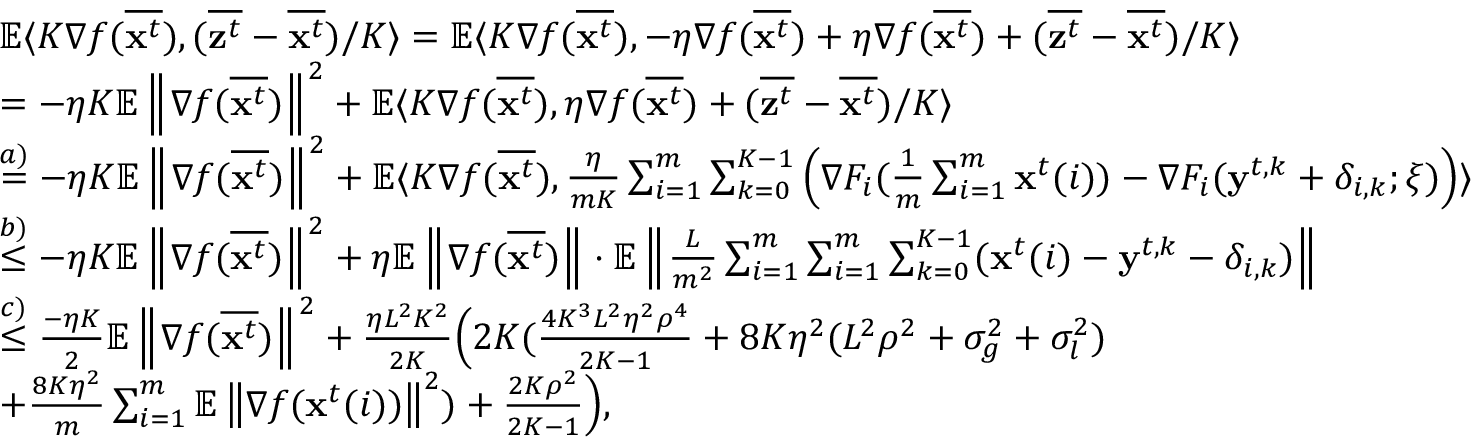<formula> <loc_0><loc_0><loc_500><loc_500>\begin{array} { r l } & { \mathbb { E } \langle K \nabla f ( \overline { { x ^ { t } } } ) , ( \overline { { z ^ { t } } } - \overline { { x ^ { t } } } ) / K \rangle = \mathbb { E } \langle K \nabla f ( \overline { { { x } ^ { t } } } ) , - \eta \nabla f ( \overline { { { x } ^ { t } } } ) + \eta \nabla f ( \overline { { { x } ^ { t } } } ) + ( \overline { { { z } ^ { t } } } - \overline { { { x } ^ { t } } } ) / K \rangle } \\ & { = - \eta K \mathbb { E } \left \| \nabla f ( \overline { { x ^ { t } } } ) \right \| ^ { 2 } + \mathbb { E } \langle K \nabla f ( \overline { { { x } ^ { t } } } ) , \eta \nabla f ( \overline { { { x } ^ { t } } } ) + ( \overline { { { z } ^ { t } } } - \overline { { { x } ^ { t } } } ) / K \rangle } \\ & { \overset { a ) } { = } - \eta K \mathbb { E } \left \| \nabla f ( \overline { { x ^ { t } } } ) \right \| ^ { 2 } + \mathbb { E } \langle K \nabla f ( \overline { { x ^ { t } } } ) , \frac { \eta } { m K } \sum _ { i = 1 } ^ { m } \sum _ { k = 0 } ^ { K - 1 } \left ( \nabla F _ { i } ( \frac { 1 } { m } \sum _ { i = 1 } ^ { m } x ^ { t } ( i ) ) - \nabla F _ { i } ( y ^ { t , k } + \delta _ { i , k } ; \xi ) \right ) \rangle } \\ & { \overset { b ) } { \leq } - \eta K \mathbb { E } \left \| \nabla f ( \overline { { x ^ { t } } } ) \right \| ^ { 2 } + \eta \mathbb { E } \left \| \nabla f ( \overline { { x ^ { t } } } ) \right \| \cdot \mathbb { E } \left \| \frac { L } { m ^ { 2 } } \sum _ { i = 1 } ^ { m } \sum _ { i = 1 } ^ { m } \sum _ { k = 0 } ^ { K - 1 } ( x ^ { t } ( i ) - y ^ { t , k } - \delta _ { i , k } ) \right \| } \\ & { \overset { c ) } { \leq } \frac { - \eta K } { 2 } \mathbb { E } \left \| \nabla f ( \overline { { x ^ { t } } } ) \right \| ^ { 2 } + \frac { \eta L ^ { 2 } K ^ { 2 } } { 2 K } \left ( 2 K ( \frac { 4 K ^ { 3 } L ^ { 2 } \eta ^ { 2 } \rho ^ { 4 } } { 2 K - 1 } + 8 K \eta ^ { 2 } ( L ^ { 2 } \rho ^ { 2 } + \sigma _ { g } ^ { 2 } + \sigma _ { l } ^ { 2 } ) } \\ & { + \frac { 8 K \eta ^ { 2 } } { m } \sum _ { i = 1 } ^ { m } \mathbb { E } \left \| \nabla f ( x ^ { t } ( i ) ) \right \| ^ { 2 } ) + \frac { 2 K \rho ^ { 2 } } { 2 K - 1 } \right ) , } \end{array}</formula> 